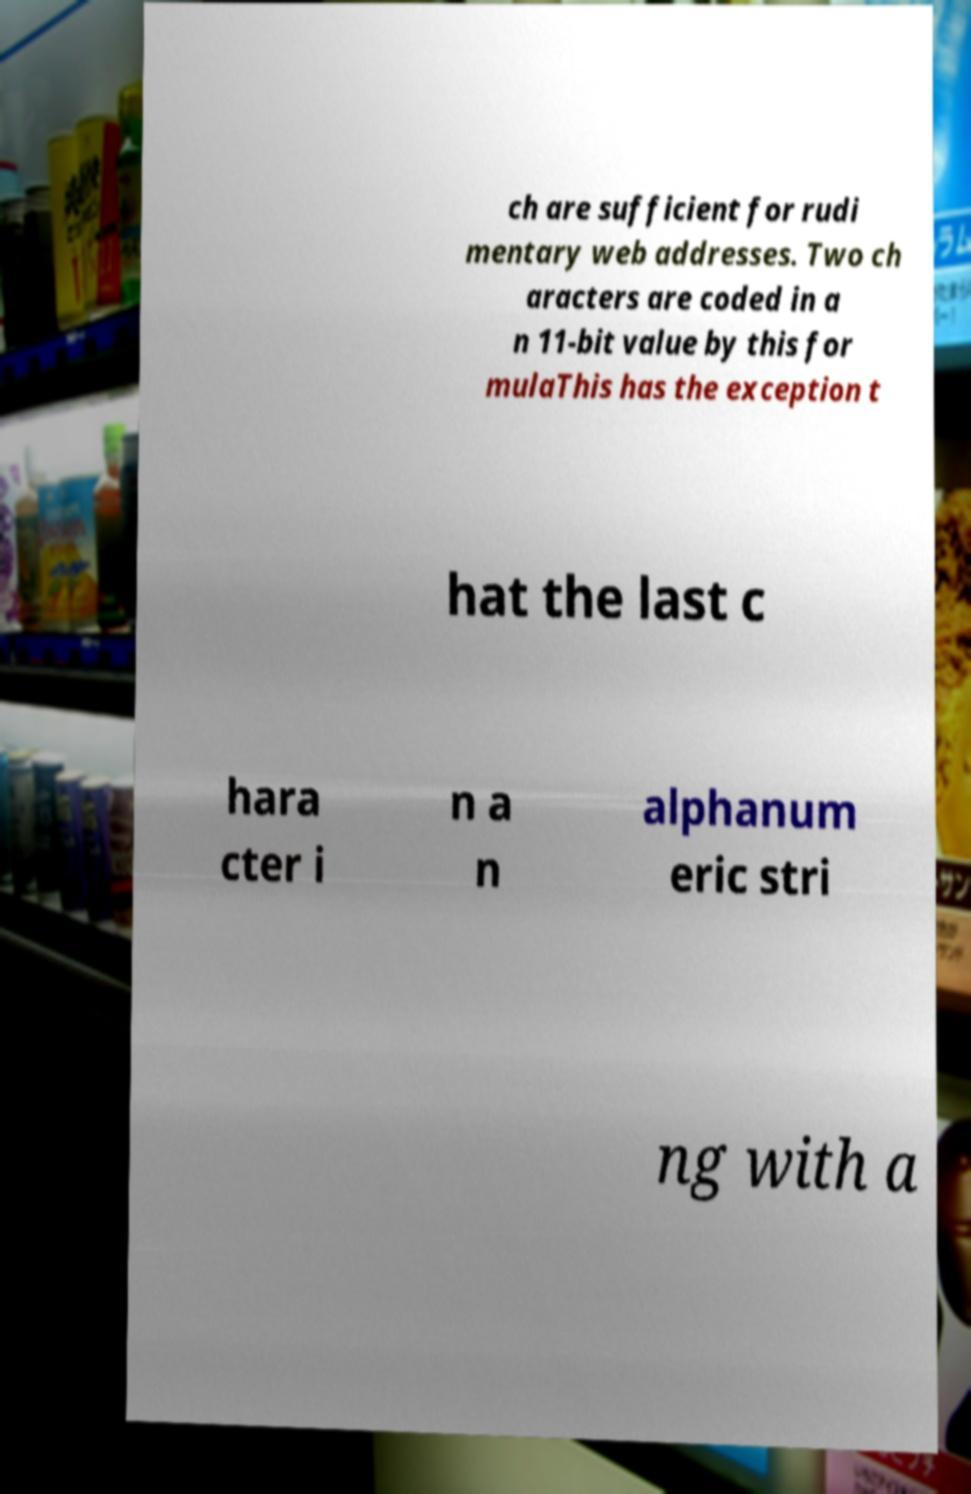Could you extract and type out the text from this image? ch are sufficient for rudi mentary web addresses. Two ch aracters are coded in a n 11-bit value by this for mulaThis has the exception t hat the last c hara cter i n a n alphanum eric stri ng with a 